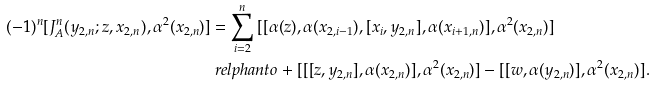Convert formula to latex. <formula><loc_0><loc_0><loc_500><loc_500>( - 1 ) ^ { n } [ J ^ { n } _ { A } ( y _ { 2 , n } ; z , x _ { 2 , n } ) , \alpha ^ { 2 } ( x _ { 2 , n } ) ] & = \sum _ { i = 2 } ^ { n } \, [ [ \alpha ( z ) , \alpha ( x _ { 2 , i - 1 } ) , [ x _ { i } , y _ { 2 , n } ] , \alpha ( x _ { i + 1 , n } ) ] , \alpha ^ { 2 } ( x _ { 2 , n } ) ] \\ & \ r e l p h a n t o + [ [ [ z , y _ { 2 , n } ] , \alpha ( x _ { 2 , n } ) ] , \alpha ^ { 2 } ( x _ { 2 , n } ) ] - [ [ w , \alpha ( y _ { 2 , n } ) ] , \alpha ^ { 2 } ( x _ { 2 , n } ) ] .</formula> 